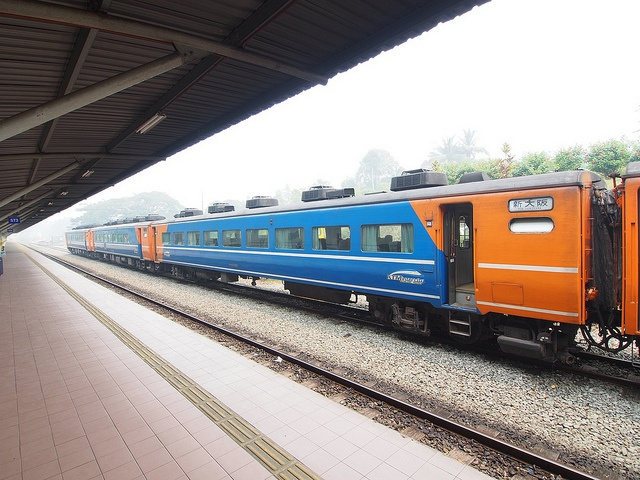Describe the objects in this image and their specific colors. I can see a train in black, red, lightgray, and gray tones in this image. 